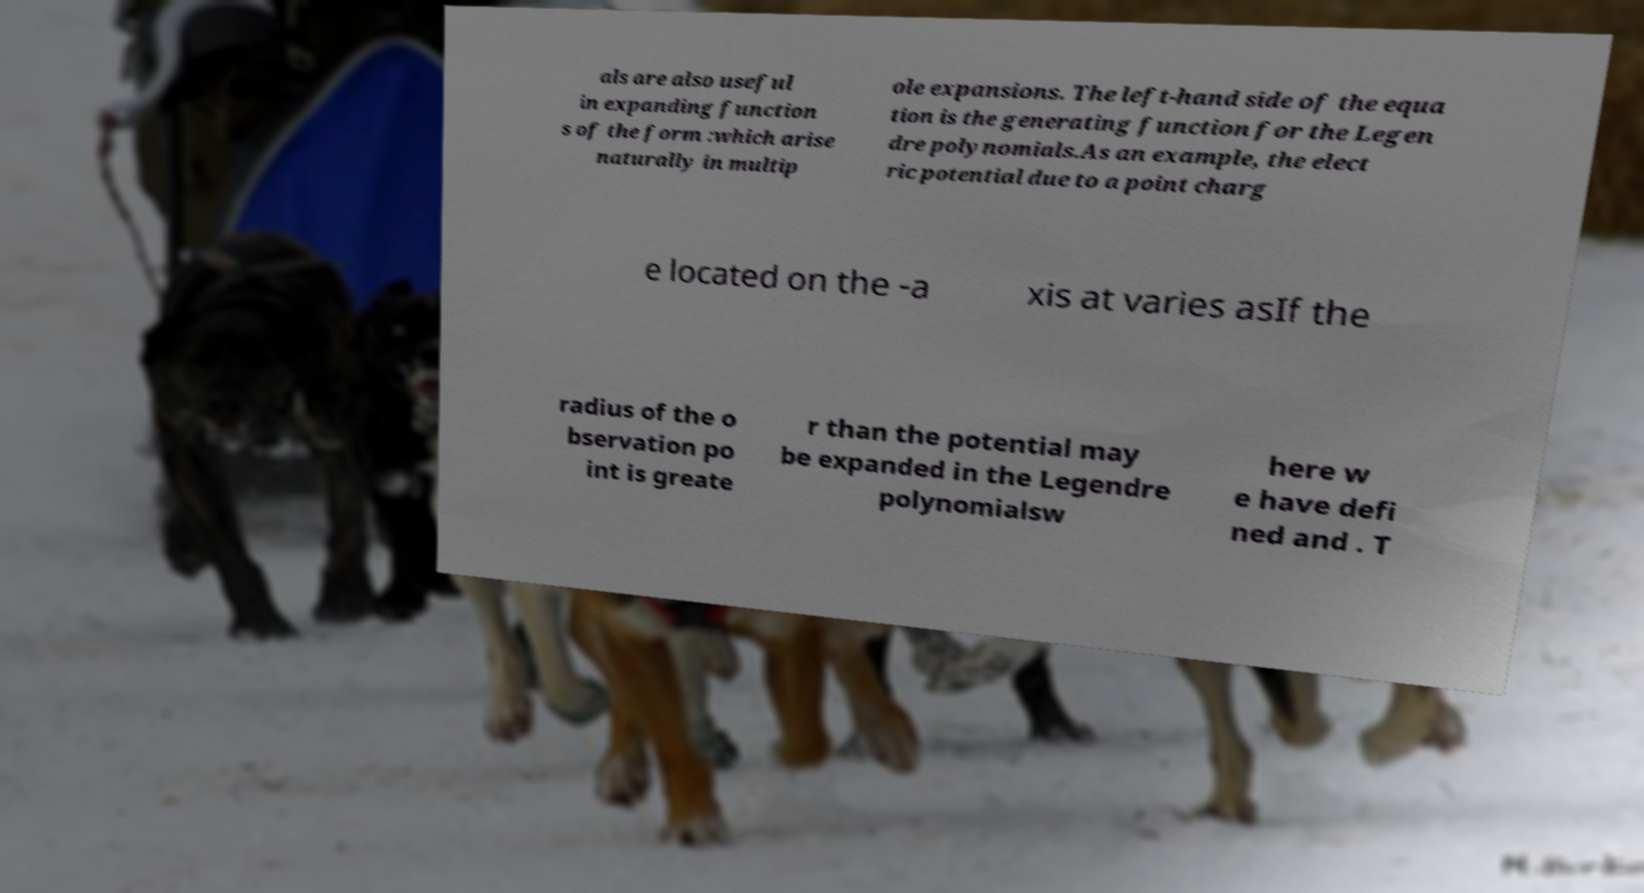Please read and relay the text visible in this image. What does it say? als are also useful in expanding function s of the form :which arise naturally in multip ole expansions. The left-hand side of the equa tion is the generating function for the Legen dre polynomials.As an example, the elect ric potential due to a point charg e located on the -a xis at varies asIf the radius of the o bservation po int is greate r than the potential may be expanded in the Legendre polynomialsw here w e have defi ned and . T 